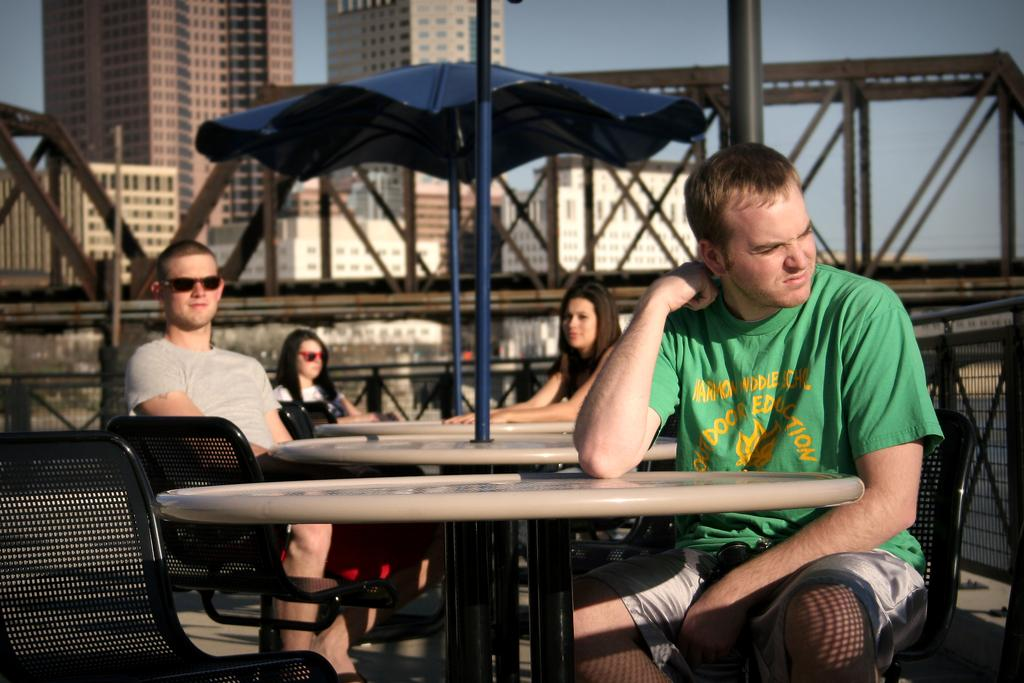How many people are present in the image? There are four people in the image. What are the people doing in the image? The people are sitting on chairs. What can be seen in the background of the image? There is a building and the sky visible in the background of the image. What type of stick can be seen in the hands of the people in the image? There is no stick present in the hands of the people in the image. 